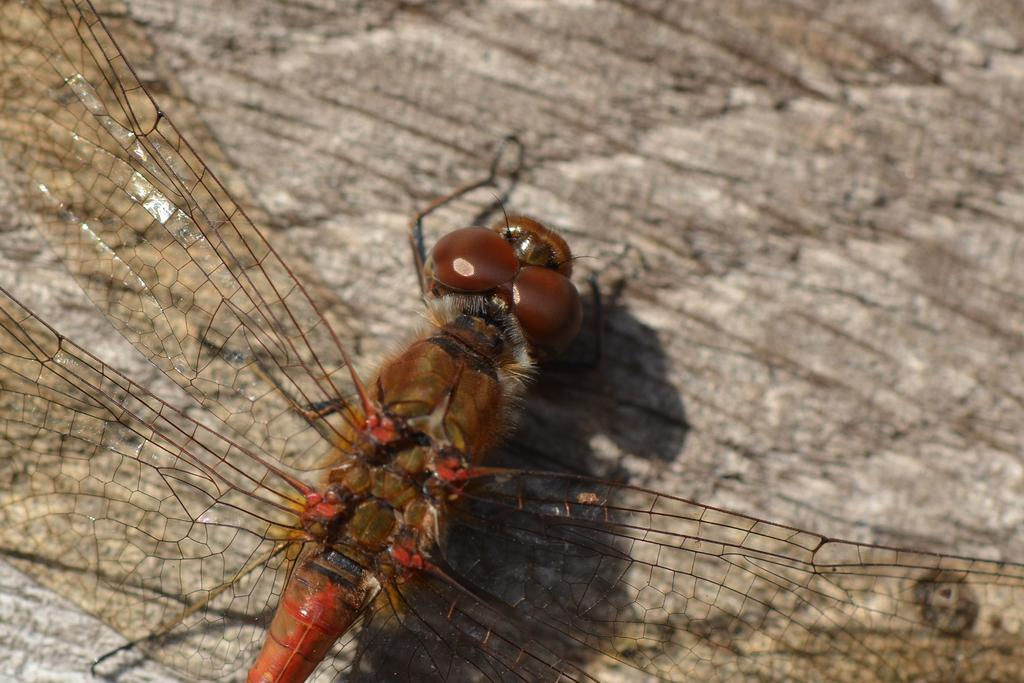What is present in the image? There is a fly in the image. What is the fly sitting on? The fly is on a brown surface. What type of pet is visible in the image? There is no pet present in the image; it only features a fly on a brown surface. 